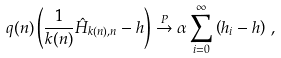<formula> <loc_0><loc_0><loc_500><loc_500>q ( n ) \left ( \frac { 1 } { k ( n ) } \hat { H } _ { k ( n ) , n } - h \right ) \stackrel { P } { \to } \alpha \sum _ { i = 0 } ^ { \infty } \left ( h _ { i } - h \right ) \, ,</formula> 